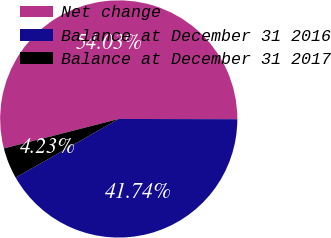Convert chart to OTSL. <chart><loc_0><loc_0><loc_500><loc_500><pie_chart><fcel>Net change<fcel>Balance at December 31 2016<fcel>Balance at December 31 2017<nl><fcel>54.03%<fcel>41.74%<fcel>4.23%<nl></chart> 